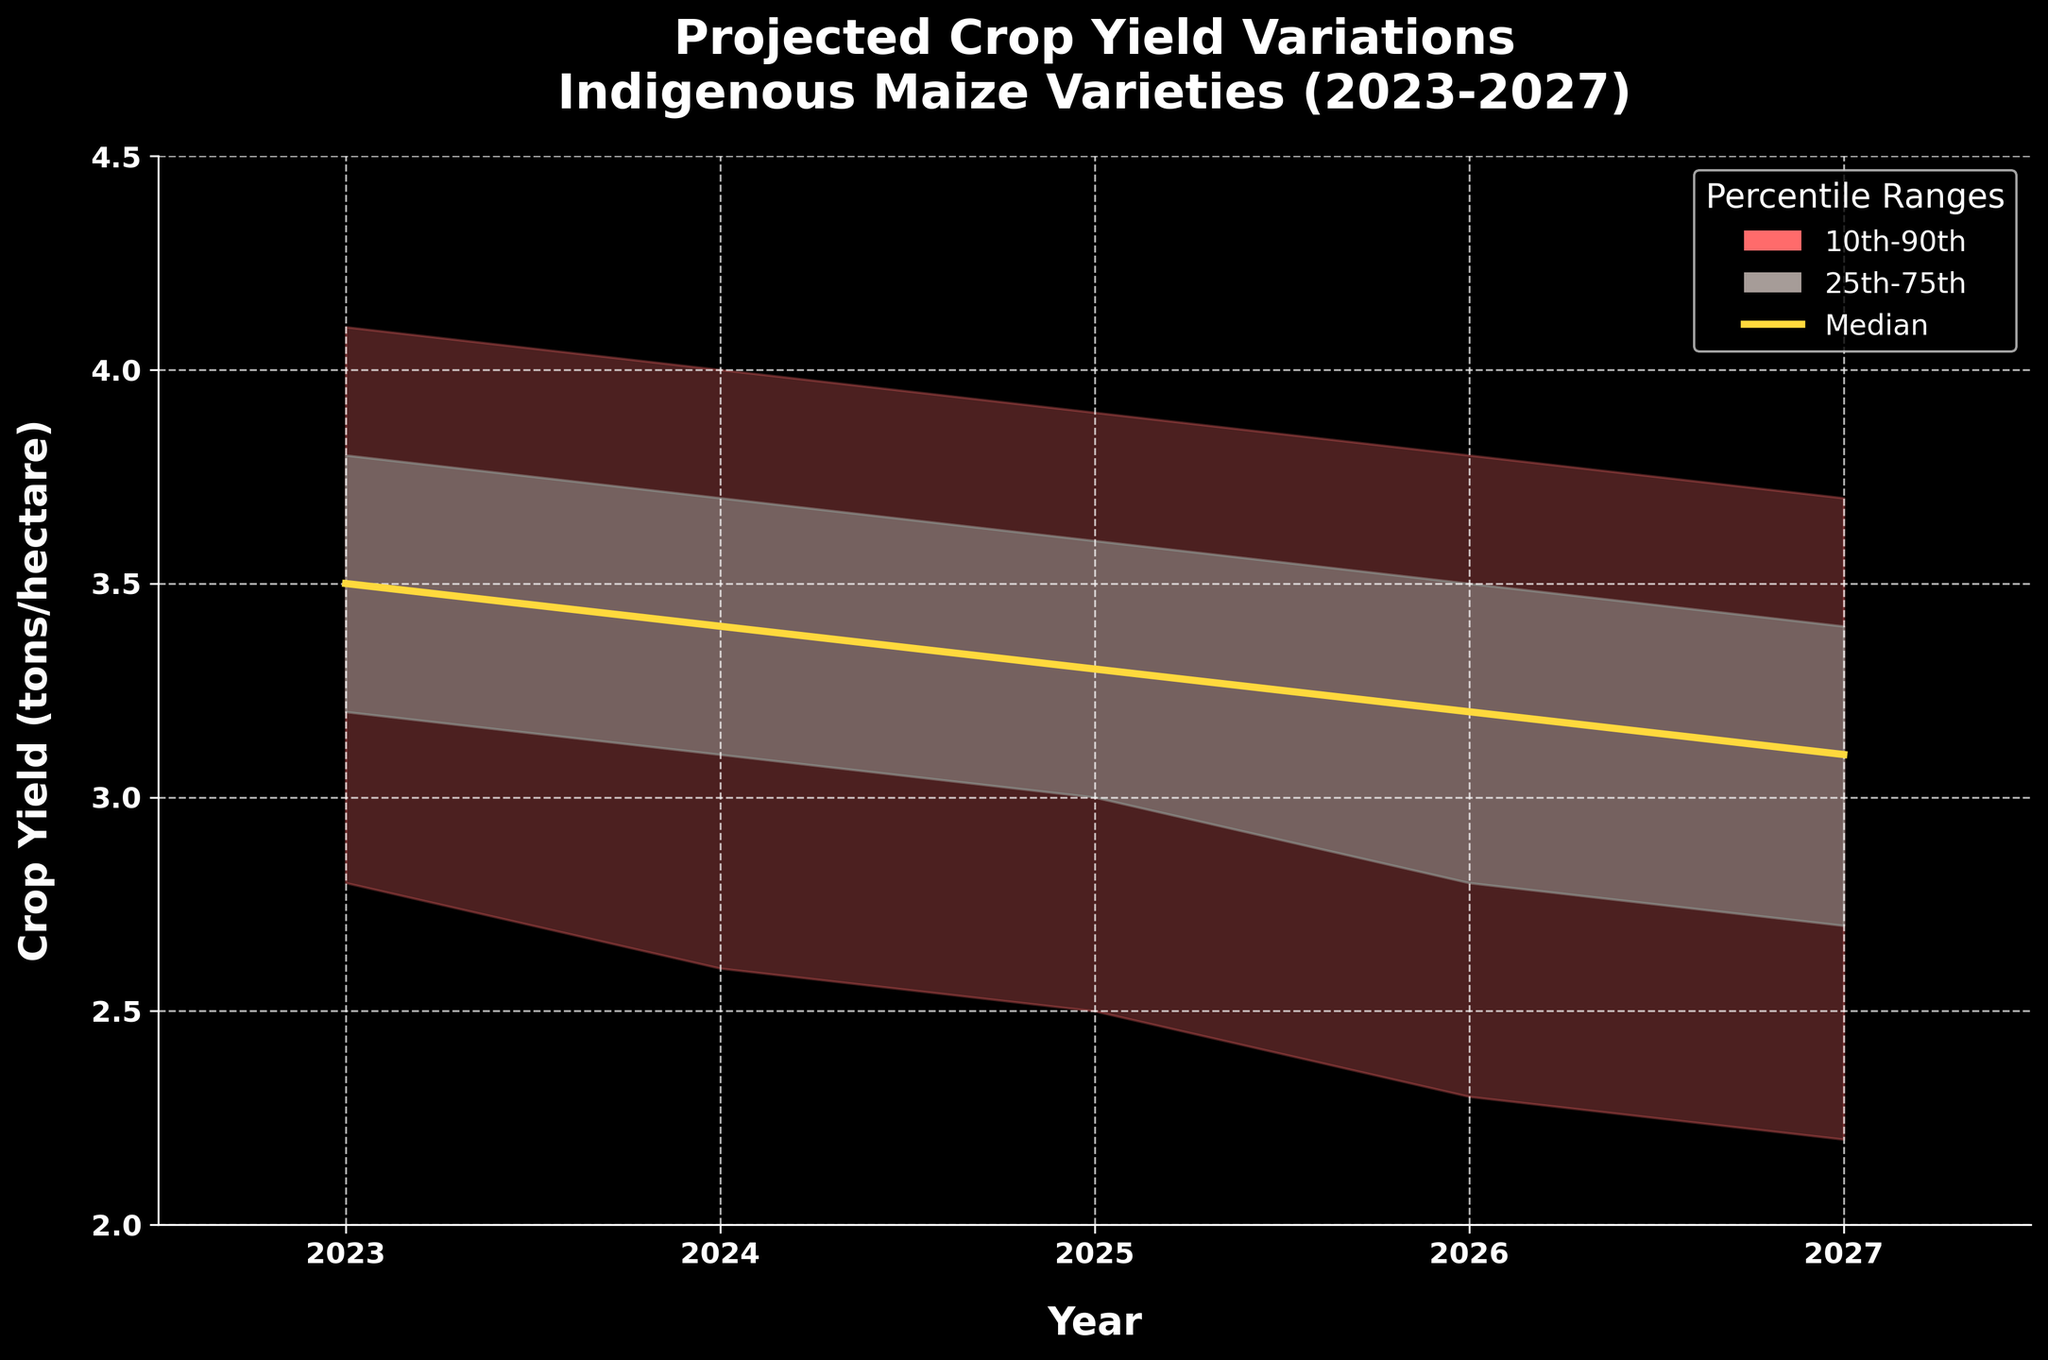What is the median projected crop yield for 2025? The median projected crop yield for each year is represented by the yellow line labeled "Median". For 2025, follow the yellow line to the year 2025 on the x-axis.
Answer: 3.3 What is the range between the 10th and 90th percentiles for 2024? For 2024, look at the values for P10 and P90. These are 2.6 and 4.0 respectively. Subtract 2.6 from 4.0 to get the range.
Answer: 1.4 How does the median projected crop yield change from 2023 to 2027? Compare the median values (P50) of 2023 and 2027. For 2023, the value is 3.5, and for 2027, it is 3.1. Find the difference by subtracting 3.1 from 3.5.
Answer: -0.4 In which year is the projected crop yield the lowest according to the 10th percentile? Look at the values for P10 across the years. The values are 2.8 (2023), 2.6 (2024), 2.5 (2025), 2.3 (2026), and 2.2 (2027). The lowest value is 2.2 in 2027.
Answer: 2027 What is the range between the 25th and 75th percentiles for 2026, and how does it compare to the range for 2023? For 2026, the values for P25 and P75 are 2.8 and 3.5 respectively. For 2023, they are 3.2 and 3.8. Calculate the range for both years: (3.5 - 2.8) = 0.7 for 2026, and (3.8 - 3.2) = 0.6 for 2023. Compare these two ranges.
Answer: 0.1 Which year has the highest value according to the 90th percentile and what is that value? The values for P90 are 4.1 (2023), 4.0 (2024), 3.9 (2025), 3.8 (2026), and 3.7 (2027). The highest value is 4.1 in 2023.
Answer: 4.1 By how much is the median crop yield expected to decrease from 2023 to 2026? The median crop yields (P50) are 3.5 (2023) and 3.2 (2026). Subtract 3.2 from 3.5 to get the decrease.
Answer: 0.3 Is the projected crop yield range (10th to 90th percentile) wider in 2024 or 2027? For 2024, the range is 4.0 (P90) - 2.6 (P10) = 1.4. For 2027, the range is 3.7 (P90) - 2.2 (P10) = 1.5. Compare these two ranges to see which is wider.
Answer: 2027 